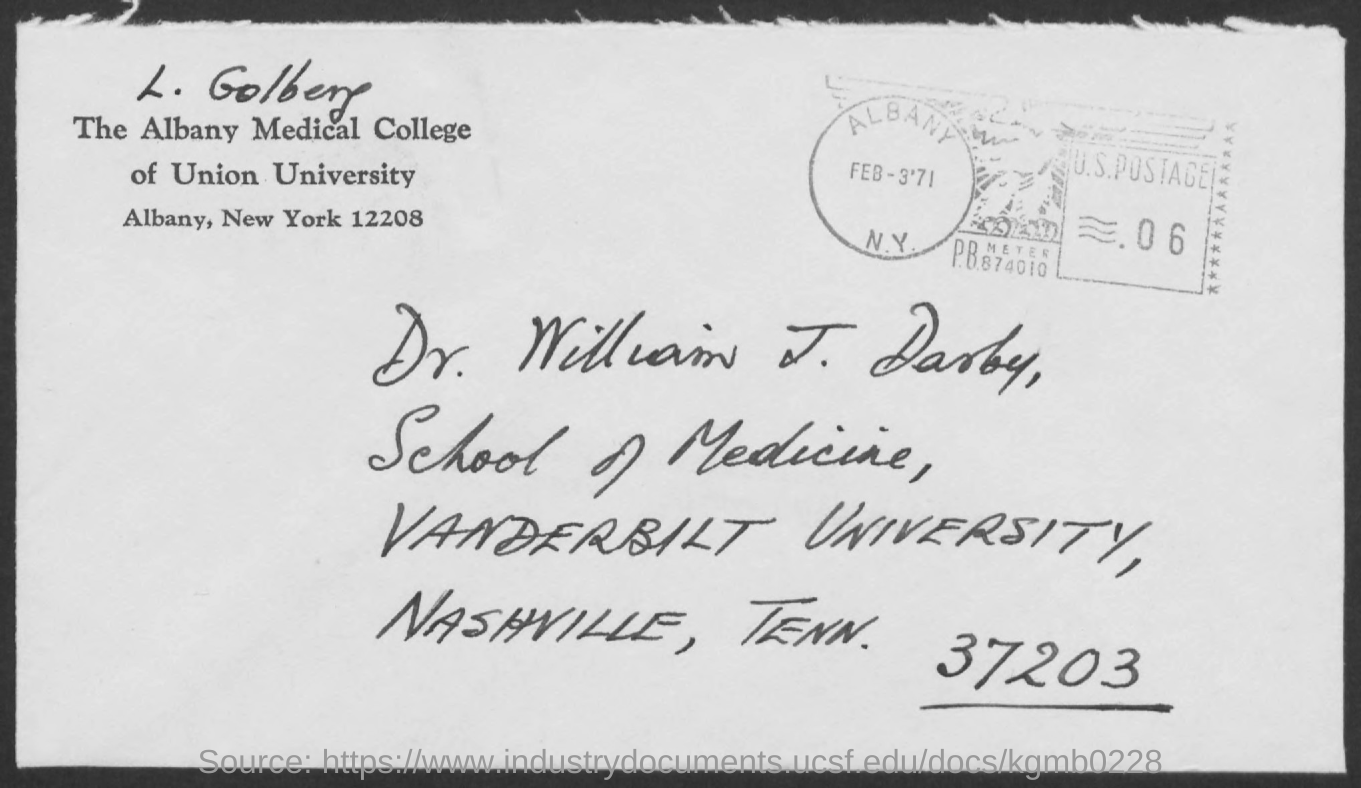Outline some significant characteristics in this image. Dr. William J. Darby is from Vanderbilt University, as per his address. L. Golberg is affiliated with The Albany Medical College of Union University, based on the provided address. 